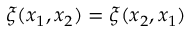Convert formula to latex. <formula><loc_0><loc_0><loc_500><loc_500>\xi ( x _ { 1 } , x _ { 2 } ) = \xi ( x _ { 2 } , x _ { 1 } )</formula> 